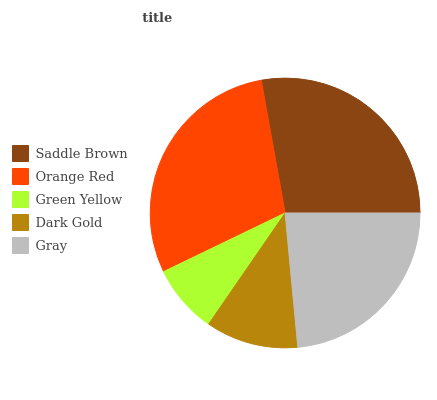Is Green Yellow the minimum?
Answer yes or no. Yes. Is Orange Red the maximum?
Answer yes or no. Yes. Is Orange Red the minimum?
Answer yes or no. No. Is Green Yellow the maximum?
Answer yes or no. No. Is Orange Red greater than Green Yellow?
Answer yes or no. Yes. Is Green Yellow less than Orange Red?
Answer yes or no. Yes. Is Green Yellow greater than Orange Red?
Answer yes or no. No. Is Orange Red less than Green Yellow?
Answer yes or no. No. Is Gray the high median?
Answer yes or no. Yes. Is Gray the low median?
Answer yes or no. Yes. Is Orange Red the high median?
Answer yes or no. No. Is Saddle Brown the low median?
Answer yes or no. No. 